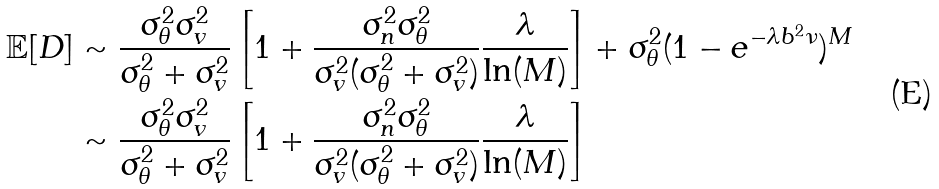Convert formula to latex. <formula><loc_0><loc_0><loc_500><loc_500>\mathbb { E } [ D ] & \sim \frac { \sigma _ { \theta } ^ { 2 } \sigma _ { v } ^ { 2 } } { \sigma _ { \theta } ^ { 2 } + \sigma _ { v } ^ { 2 } } \left [ 1 + \frac { \sigma _ { n } ^ { 2 } \sigma _ { \theta } ^ { 2 } } { \sigma _ { v } ^ { 2 } ( \sigma _ { \theta } ^ { 2 } + \sigma _ { v } ^ { 2 } ) } \frac { \lambda } { \ln ( M ) } \right ] + \sigma _ { \theta } ^ { 2 } ( 1 - e ^ { - \lambda b ^ { 2 } \nu } ) ^ { M } \\ & \sim \frac { \sigma _ { \theta } ^ { 2 } \sigma _ { v } ^ { 2 } } { \sigma _ { \theta } ^ { 2 } + \sigma _ { v } ^ { 2 } } \left [ 1 + \frac { \sigma _ { n } ^ { 2 } \sigma _ { \theta } ^ { 2 } } { \sigma _ { v } ^ { 2 } ( \sigma _ { \theta } ^ { 2 } + \sigma _ { v } ^ { 2 } ) } \frac { \lambda } { \ln ( M ) } \right ]</formula> 